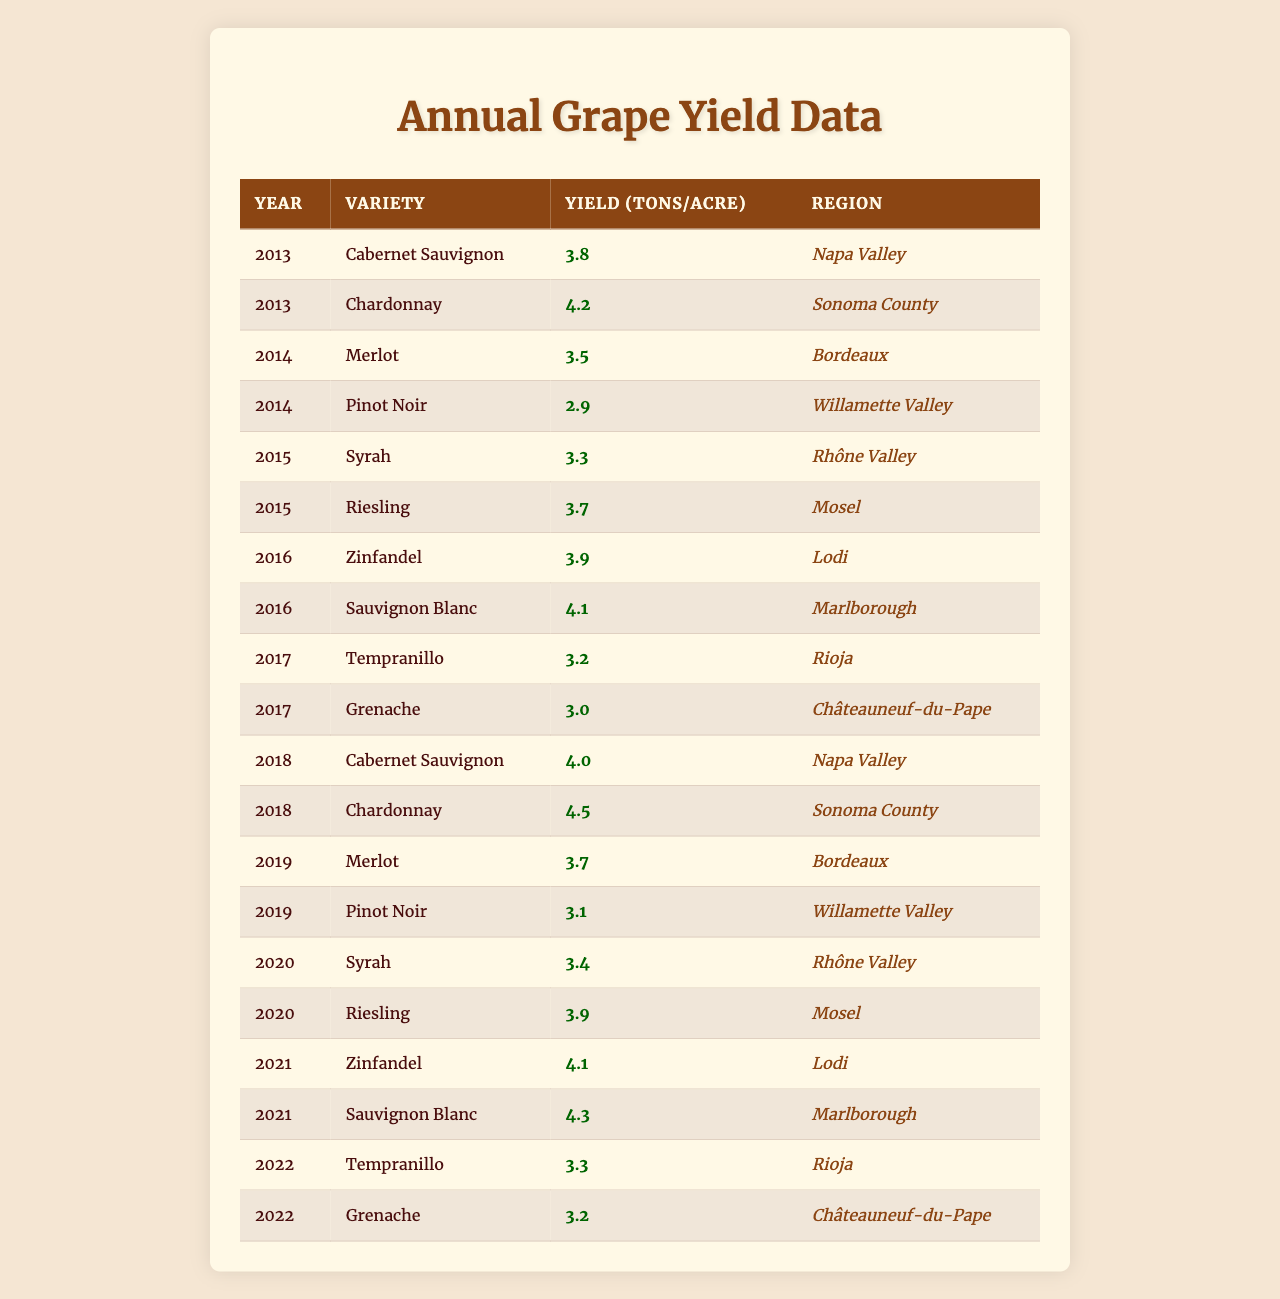What was the highest yield recorded in 2019? In 2019, the data shows that the highest yield was associated with Merlot, which had a yield of 3.7 tons per acre.
Answer: 3.7 tons per acre Which grape variety had the lowest yield in 2014? In 2014, the data indicates that Pinot Noir had the lowest yield of 2.9 tons per acre.
Answer: 2.9 tons per acre What is the average yield of Chardonnay across the recorded years? To find the average yield of Chardonnay, we take the yields from 2013 (4.2) and 2018 (4.5), sum them up (4.2 + 4.5 = 8.7) and divide by 2, resulting in an average yield of 4.35 tons per acre.
Answer: 4.35 tons per acre Did Zinfandel have a higher yield in 2021 than in 2016? The yield of Zinfandel in 2021 was 4.1 tons per acre, while in 2016 it was 3.9 tons per acre, confirming that Zinfandel's yield did increase in 2021 compared to 2016.
Answer: Yes What was the total yield from all grape varieties in 2016? The total yield for 2016 can be calculated by adding the yields of Zinfandel (3.9) and Sauvignon Blanc (4.1) together, resulting in a total yield of 8.0 tons per acre for the year.
Answer: 8.0 tons per acre Which region consistently produced the highest yield for Cabernet Sauvignon in the available years? The table shows Cabernet Sauvignon yielded 3.8 tons per acre in 2013 and 4.0 tons per acre in 2018, both from Napa Valley, indicating that Napa Valley consistently provided the highest yield for this variety.
Answer: Napa Valley What are the two regions where Riesling was grown, and how did their yields compare? Riesling yields were recorded in 2015 (3.7 tons per acre, Mosel) and 2020 (3.9 tons per acre, Mosel), showing that the yield slightly increased over the years but remained from the same region.
Answer: 3.7 tons (2015, Mosel) and 3.9 tons (2020, Mosel) Is it true that Tempranillo had the same yield in 2022 as in 2017? In 2017, Tempranillo had a yield of 3.2 tons per acre, while in 2022, it had a yield of 3.3 tons per acre, so it is false that they had the same yield; it increased slightly.
Answer: No Which grape variety showed the most improvement in yield from 2015 to 2021? By comparing yields, Syrah went from 3.3 tons per acre in 2015 to 3.4 tons per acre in 2020, which is an increase, but Zinfandel improved from 3.9 tons per acre in 2016 to 4.1 tons per acre in 2021, representing a 0.2-ton increase, which is the most improvement seen in the table.
Answer: Zinfandel In how many different years was Grenache recorded in the table, and what were its associated yields? Grenache was recorded in 2017 with a yield of 3.0 tons per acre and in 2022 with a yield of 3.2 tons per acre, showing that it was recorded in 2 different years.
Answer: 2 years, yields: 3.0, 3.2 tons per acre 